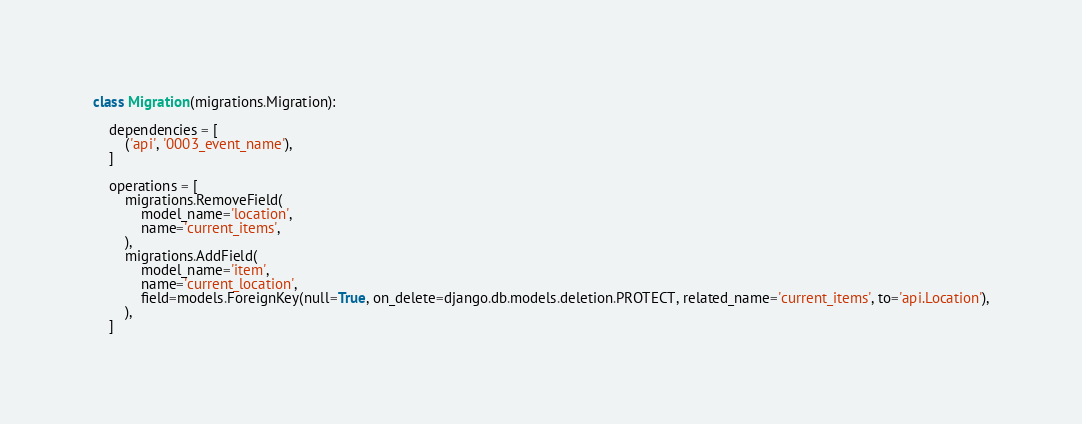<code> <loc_0><loc_0><loc_500><loc_500><_Python_>
class Migration(migrations.Migration):

    dependencies = [
        ('api', '0003_event_name'),
    ]

    operations = [
        migrations.RemoveField(
            model_name='location',
            name='current_items',
        ),
        migrations.AddField(
            model_name='item',
            name='current_location',
            field=models.ForeignKey(null=True, on_delete=django.db.models.deletion.PROTECT, related_name='current_items', to='api.Location'),
        ),
    ]
</code> 